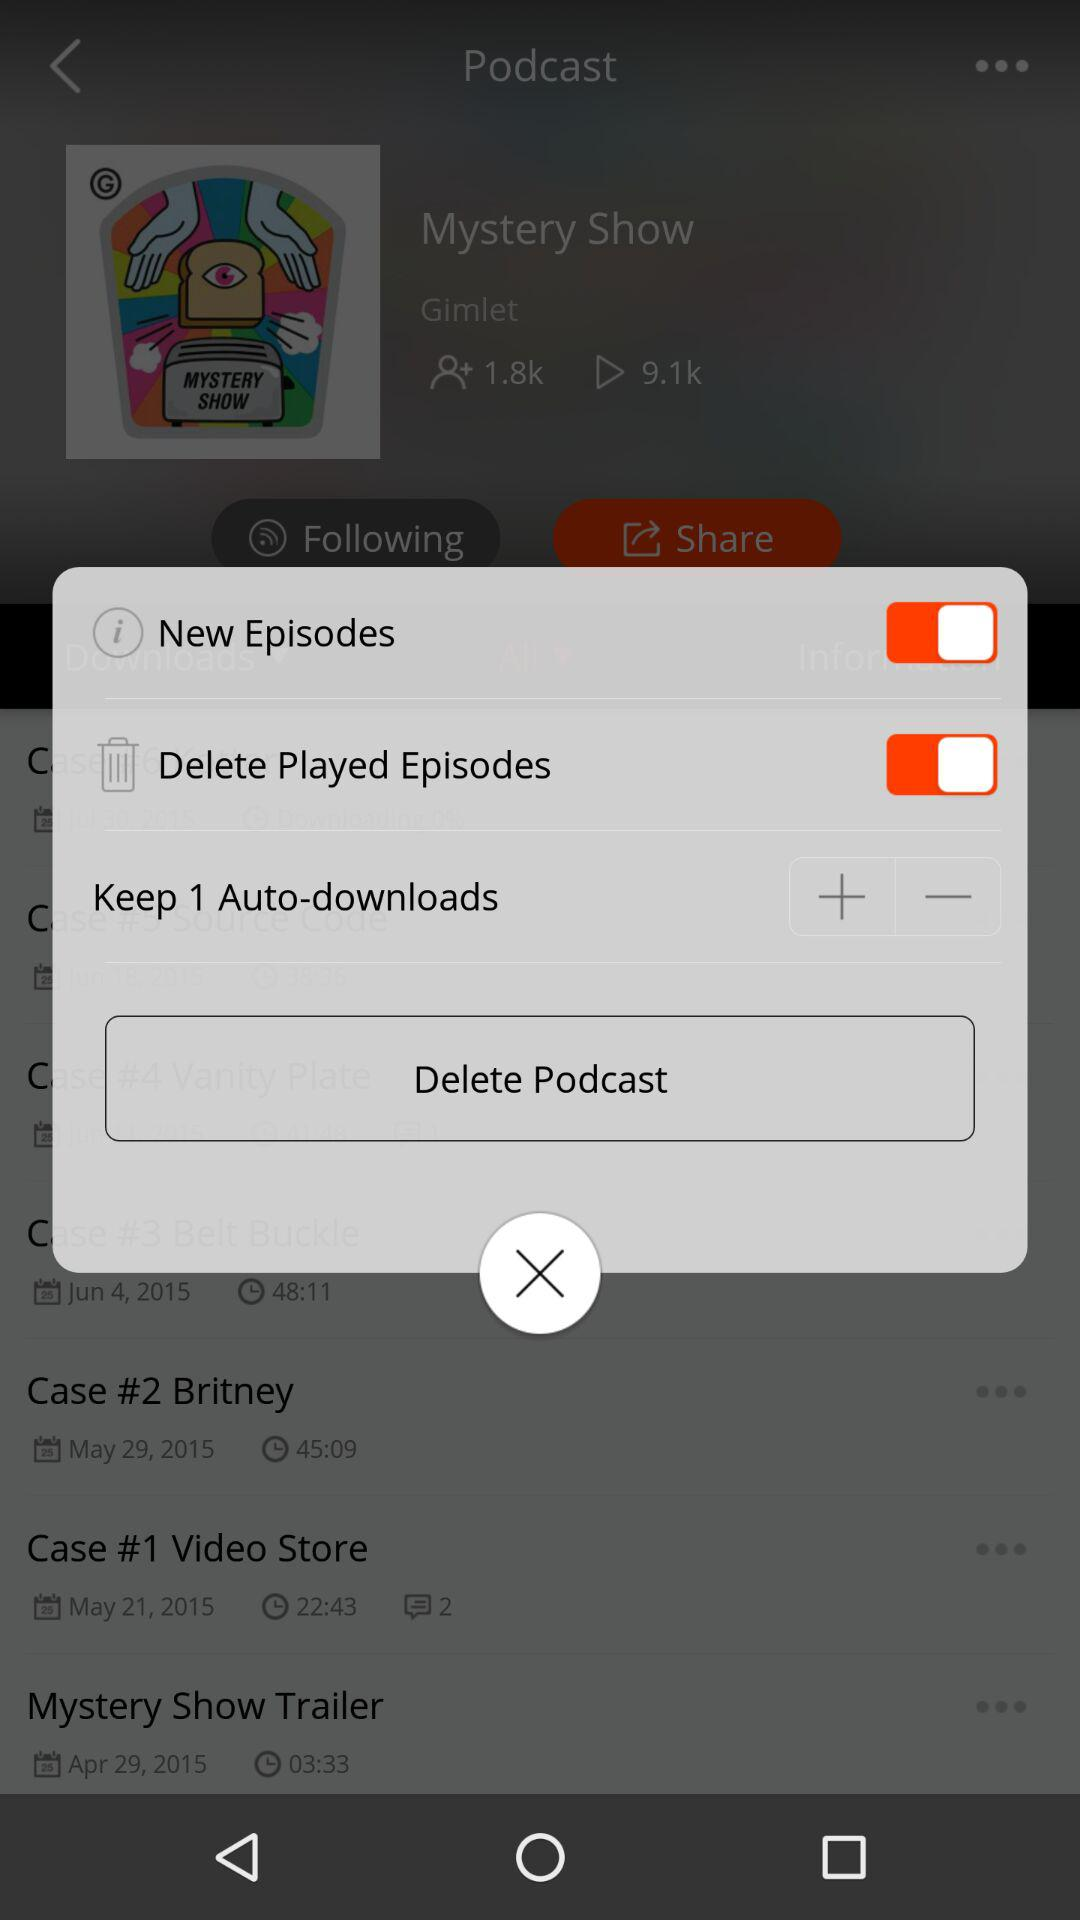How many auto-downloads are set?
Answer the question using a single word or phrase. 1 